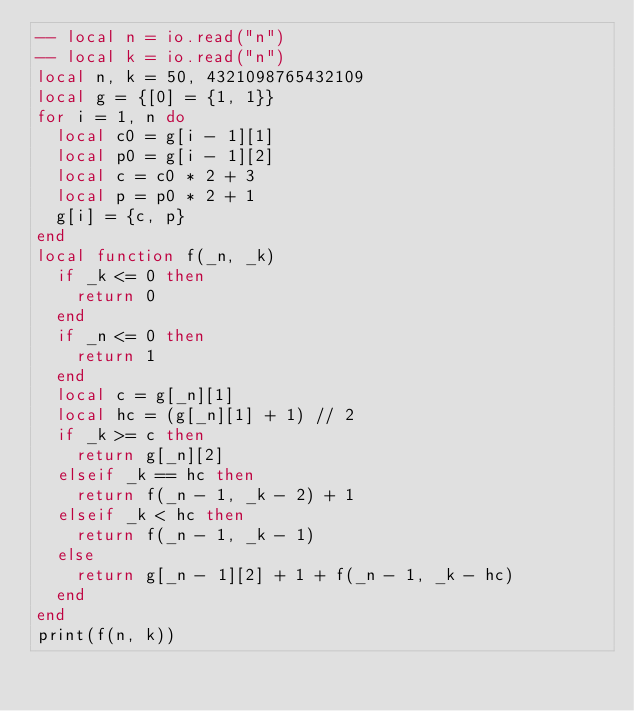Convert code to text. <code><loc_0><loc_0><loc_500><loc_500><_Lua_>-- local n = io.read("n")
-- local k = io.read("n")
local n, k = 50, 4321098765432109
local g = {[0] = {1, 1}}
for i = 1, n do
	local c0 = g[i - 1][1]
	local p0 = g[i - 1][2]
	local c = c0 * 2 + 3
	local p = p0 * 2 + 1
	g[i] = {c, p}
end
local function f(_n, _k)
	if _k <= 0 then
		return 0
	end
	if _n <= 0 then
		return 1
	end
	local c = g[_n][1]
	local hc = (g[_n][1] + 1) // 2
	if _k >= c then
		return g[_n][2]
	elseif _k == hc then
		return f(_n - 1, _k - 2) + 1
	elseif _k < hc then
		return f(_n - 1, _k - 1)
	else
		return g[_n - 1][2] + 1 + f(_n - 1, _k - hc)
	end
end
print(f(n, k))</code> 